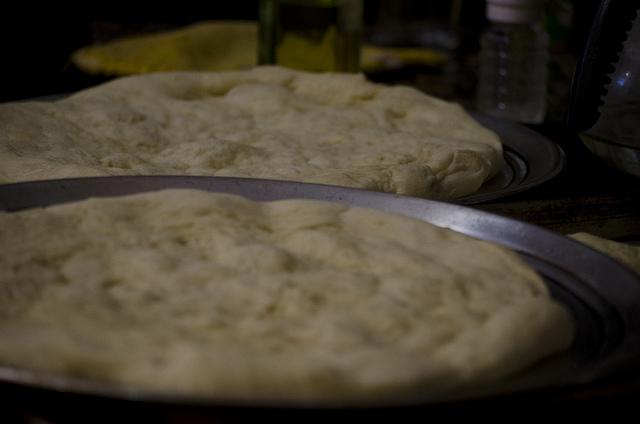Where are some likely locations that you could buy the item in the Picture?
Give a very brief answer. Pizzeria. What toppings are on the pizza dough?
Short answer required. None. Is that chicken?
Short answer required. No. What shape is the food?
Answer briefly. Round. 